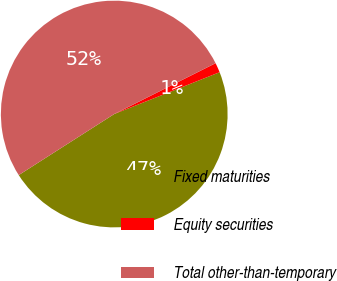Convert chart to OTSL. <chart><loc_0><loc_0><loc_500><loc_500><pie_chart><fcel>Fixed maturities<fcel>Equity securities<fcel>Total other-than-temporary<nl><fcel>46.96%<fcel>1.39%<fcel>51.65%<nl></chart> 